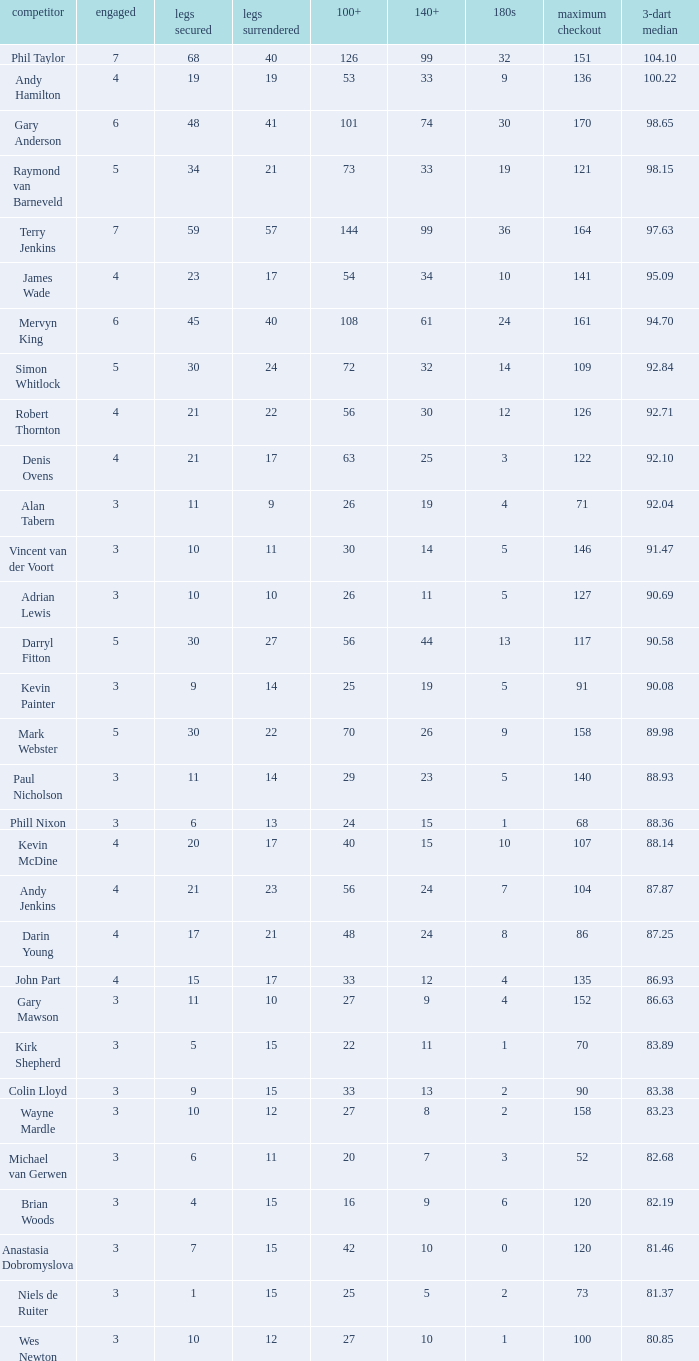What is the most legs lost of all? 57.0. 